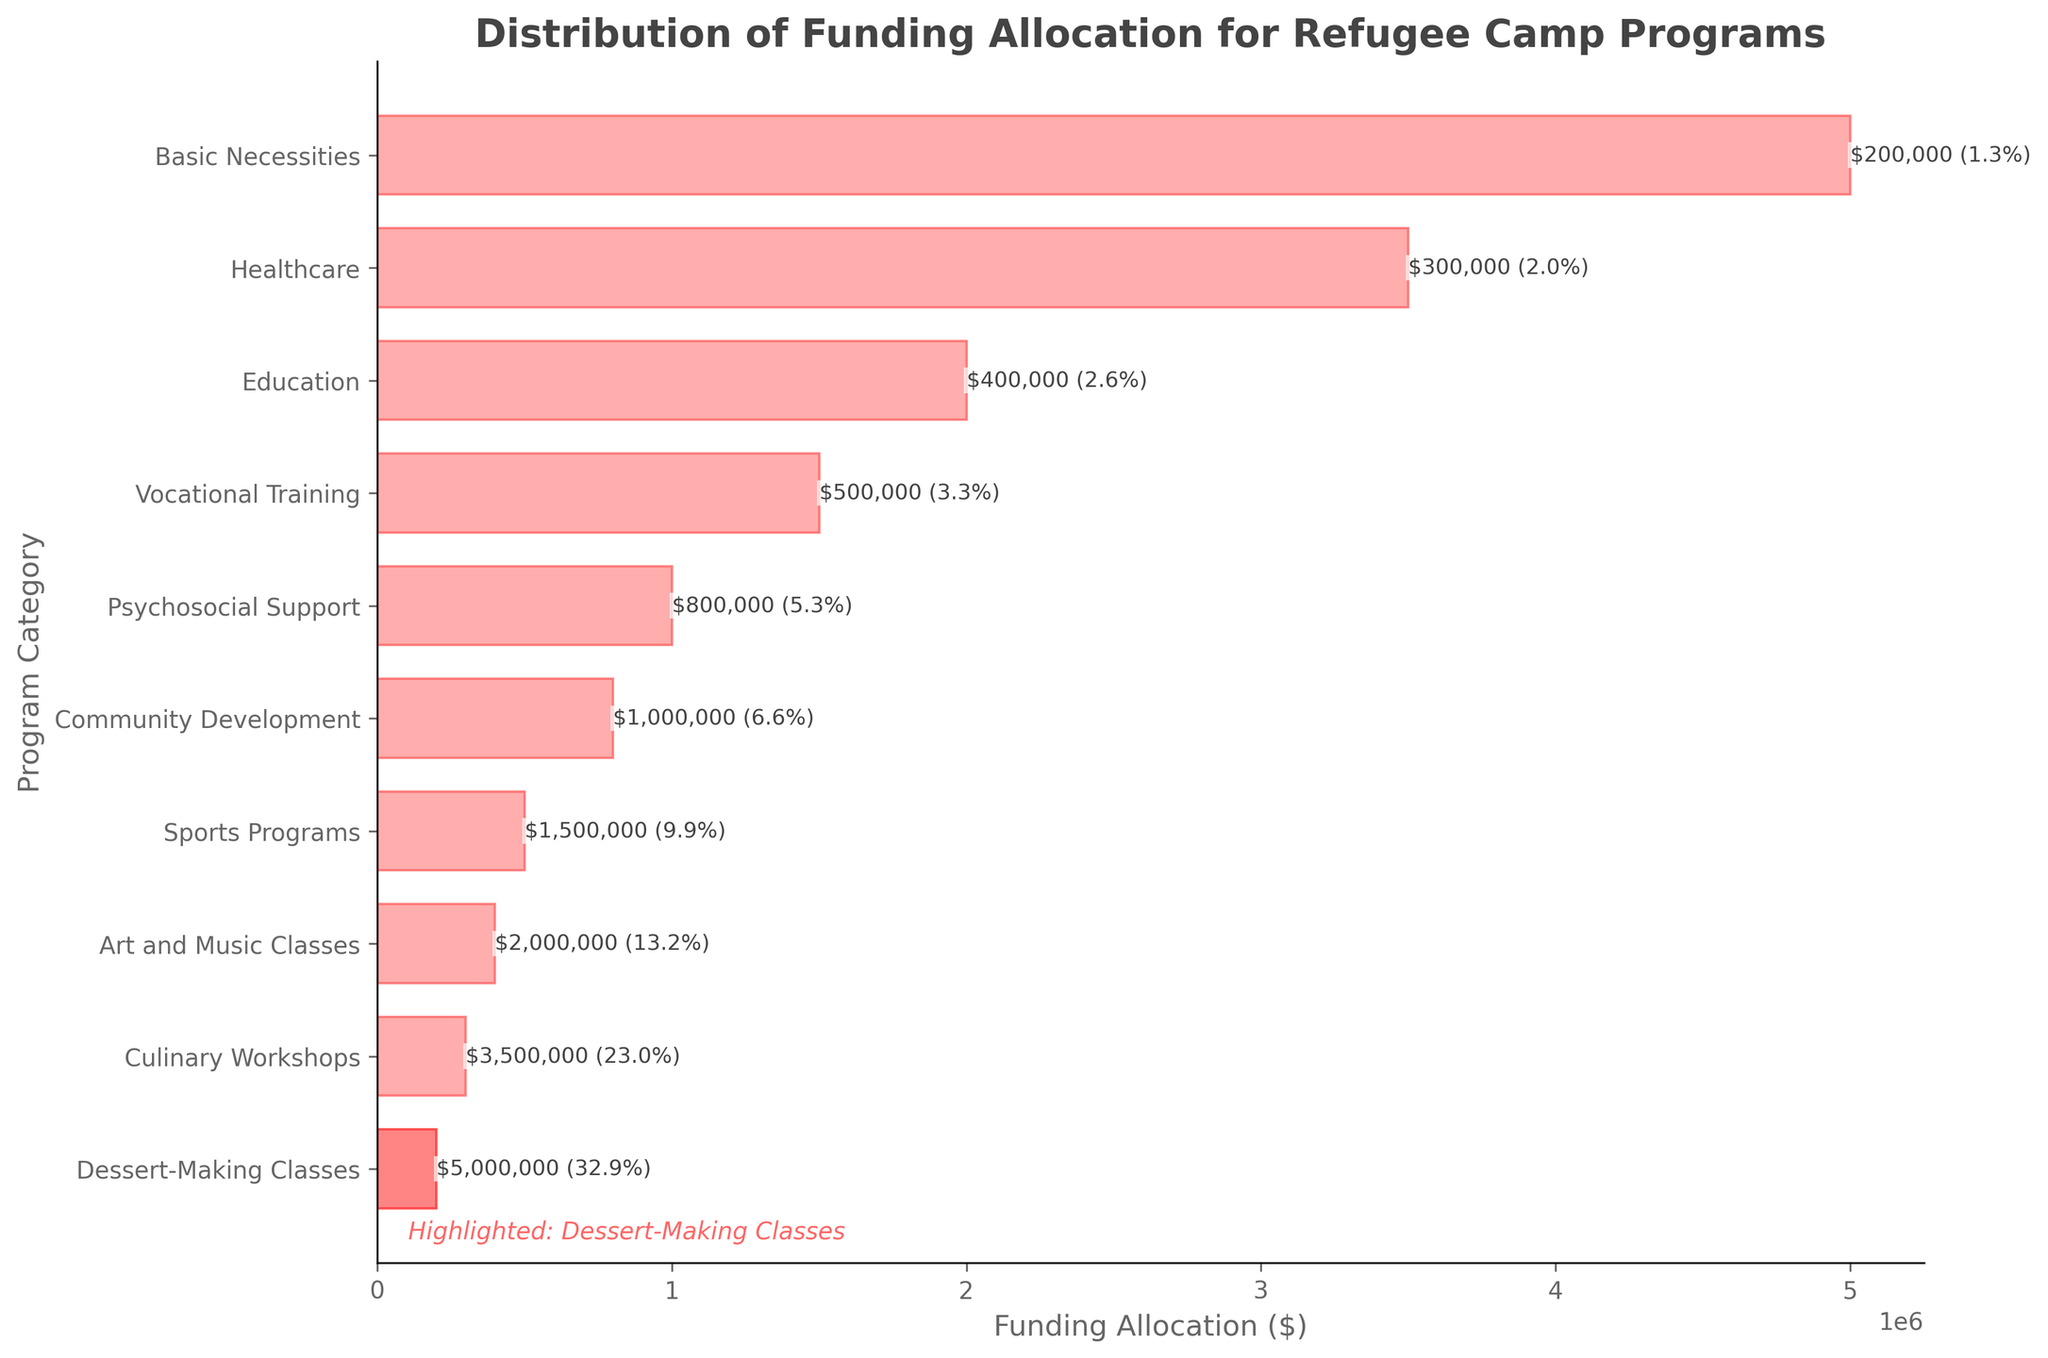What is the total funding allocated to all programs in the refugee camp? By summing all the funding allocations, we get: 5,000,000 + 3,500,000 + 2,000,000 + 1,500,000 + 1,000,000 + 800,000 + 500,000 + 400,000 + 300,000 + 200,000 = 15,200,000 USD.
Answer: 15,200,000 USD Which program received the least amount of funding? By examining the figure, the Dessert-Making Classes are highlighted and have the smallest bar, indicating the least funding of 200,000 USD.
Answer: Dessert-Making Classes What is the difference in funding between Healthcare and Education programs? The Healthcare program received 3,500,000 USD, and the Education program received 2,000,000 USD. The difference is 3,500,000 - 2,000,000 = 1,500,000 USD.
Answer: 1,500,000 USD How much more funding is allocated to Basic Necessities compared to Vocational Training? Basic Necessities received 5,000,000 USD, and Vocational Training received 1,500,000 USD. The difference is 5,000,000 - 1,500,000 = 3,500,000 USD.
Answer: 3,500,000 USD What percentage of the total funding is allocated to Culinary Workshops? Culinary Workshops received 300,000 USD. The total funding is 15,200,000 USD. The percentage is (300,000 / 15,200,000) * 100 ≈ 1.97%.
Answer: 1.97% How does the funding for Art and Music Classes compare to Sports Programs? Art and Music Classes received 400,000 USD, and Sports Programs received 500,000 USD. Therefore, Sports Programs received 100,000 USD more than Art and Music Classes.
Answer: Sports Programs received more What is the total funding allocated to programs related to education, including both education and vocational training? Education funding is 2,000,000 USD, and Vocational Training funding is 1,500,000 USD. The sum is 2,000,000 + 1,500,000 = 3,500,000 USD.
Answer: 3,500,000 USD Which basic necessity is highlighted in the plot, and why is it significant? The Dessert-Making Classes are highlighted. This signifies its unique importance despite receiving the least funding.
Answer: Dessert-Making Classes, unique importance 